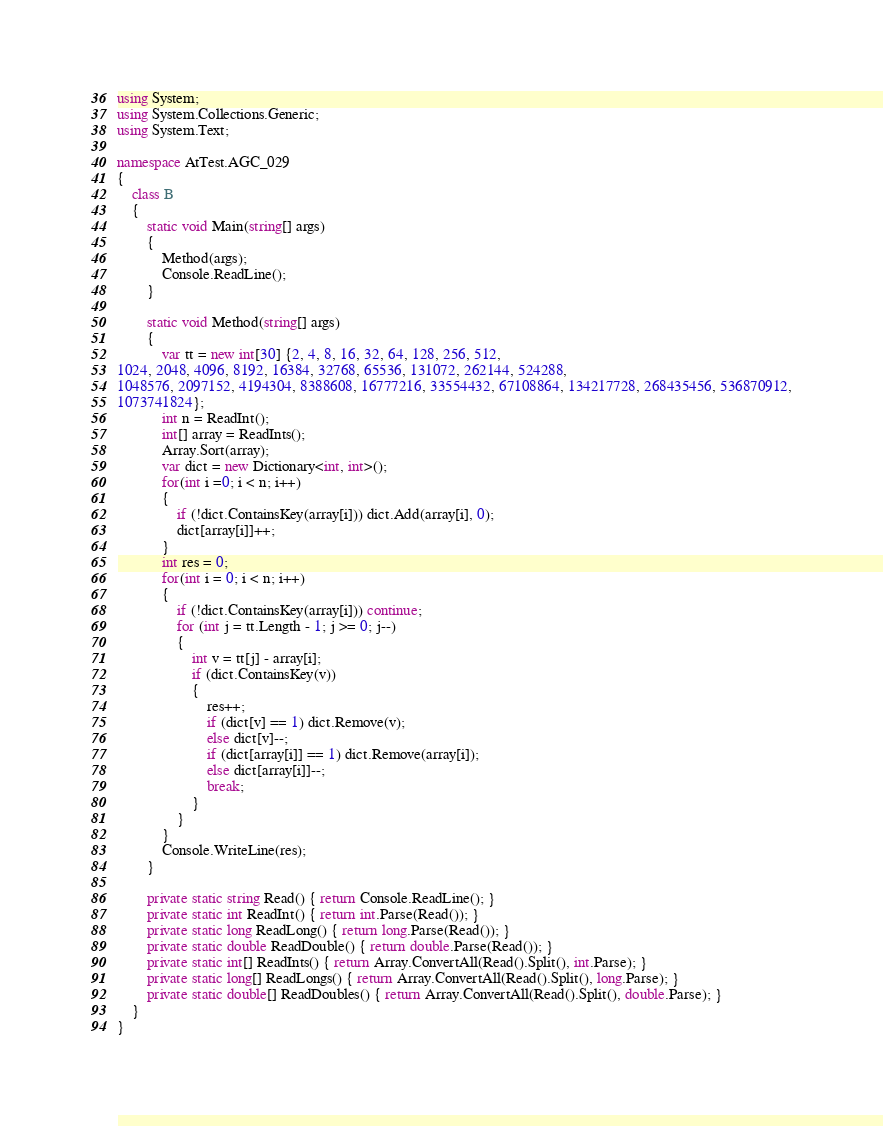Convert code to text. <code><loc_0><loc_0><loc_500><loc_500><_C#_>using System;
using System.Collections.Generic;
using System.Text;

namespace AtTest.AGC_029
{
    class B
    {
        static void Main(string[] args)
        {
            Method(args);
            Console.ReadLine();
        }

        static void Method(string[] args)
        {
            var tt = new int[30] {2, 4, 8, 16, 32, 64, 128, 256, 512,
1024, 2048, 4096, 8192, 16384, 32768, 65536, 131072, 262144, 524288,
1048576, 2097152, 4194304, 8388608, 16777216, 33554432, 67108864, 134217728, 268435456, 536870912,
1073741824};
            int n = ReadInt();
            int[] array = ReadInts();
            Array.Sort(array);
            var dict = new Dictionary<int, int>();
            for(int i =0; i < n; i++)
            {
                if (!dict.ContainsKey(array[i])) dict.Add(array[i], 0);
                dict[array[i]]++;
            }
            int res = 0;
            for(int i = 0; i < n; i++)
            {
                if (!dict.ContainsKey(array[i])) continue;
                for (int j = tt.Length - 1; j >= 0; j--)
                {
                    int v = tt[j] - array[i];
                    if (dict.ContainsKey(v))
                    {
                        res++;
                        if (dict[v] == 1) dict.Remove(v);
                        else dict[v]--;
                        if (dict[array[i]] == 1) dict.Remove(array[i]);
                        else dict[array[i]]--;
                        break;
                    }
                }
            }
            Console.WriteLine(res);
        }

        private static string Read() { return Console.ReadLine(); }
        private static int ReadInt() { return int.Parse(Read()); }
        private static long ReadLong() { return long.Parse(Read()); }
        private static double ReadDouble() { return double.Parse(Read()); }
        private static int[] ReadInts() { return Array.ConvertAll(Read().Split(), int.Parse); }
        private static long[] ReadLongs() { return Array.ConvertAll(Read().Split(), long.Parse); }
        private static double[] ReadDoubles() { return Array.ConvertAll(Read().Split(), double.Parse); }
    }
}
</code> 